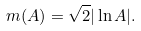Convert formula to latex. <formula><loc_0><loc_0><loc_500><loc_500>m ( A ) = \sqrt { 2 } | \ln A | .</formula> 